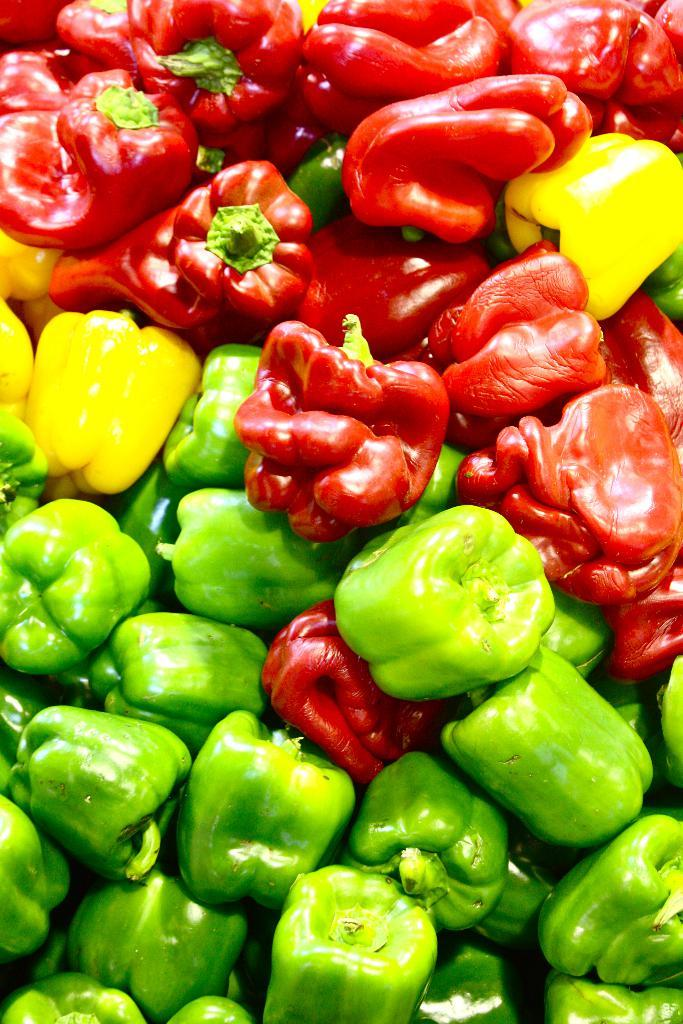What types of capsicums can be seen in the image? There are different colors of capsicums in the image, including yellow, green, and red. How many quarters can be seen in the image? There are no quarters present in the image; it features different colors of capsicums. What type of bean is visible in the image? There are no beans present in the image; it features different colors of capsicums. 